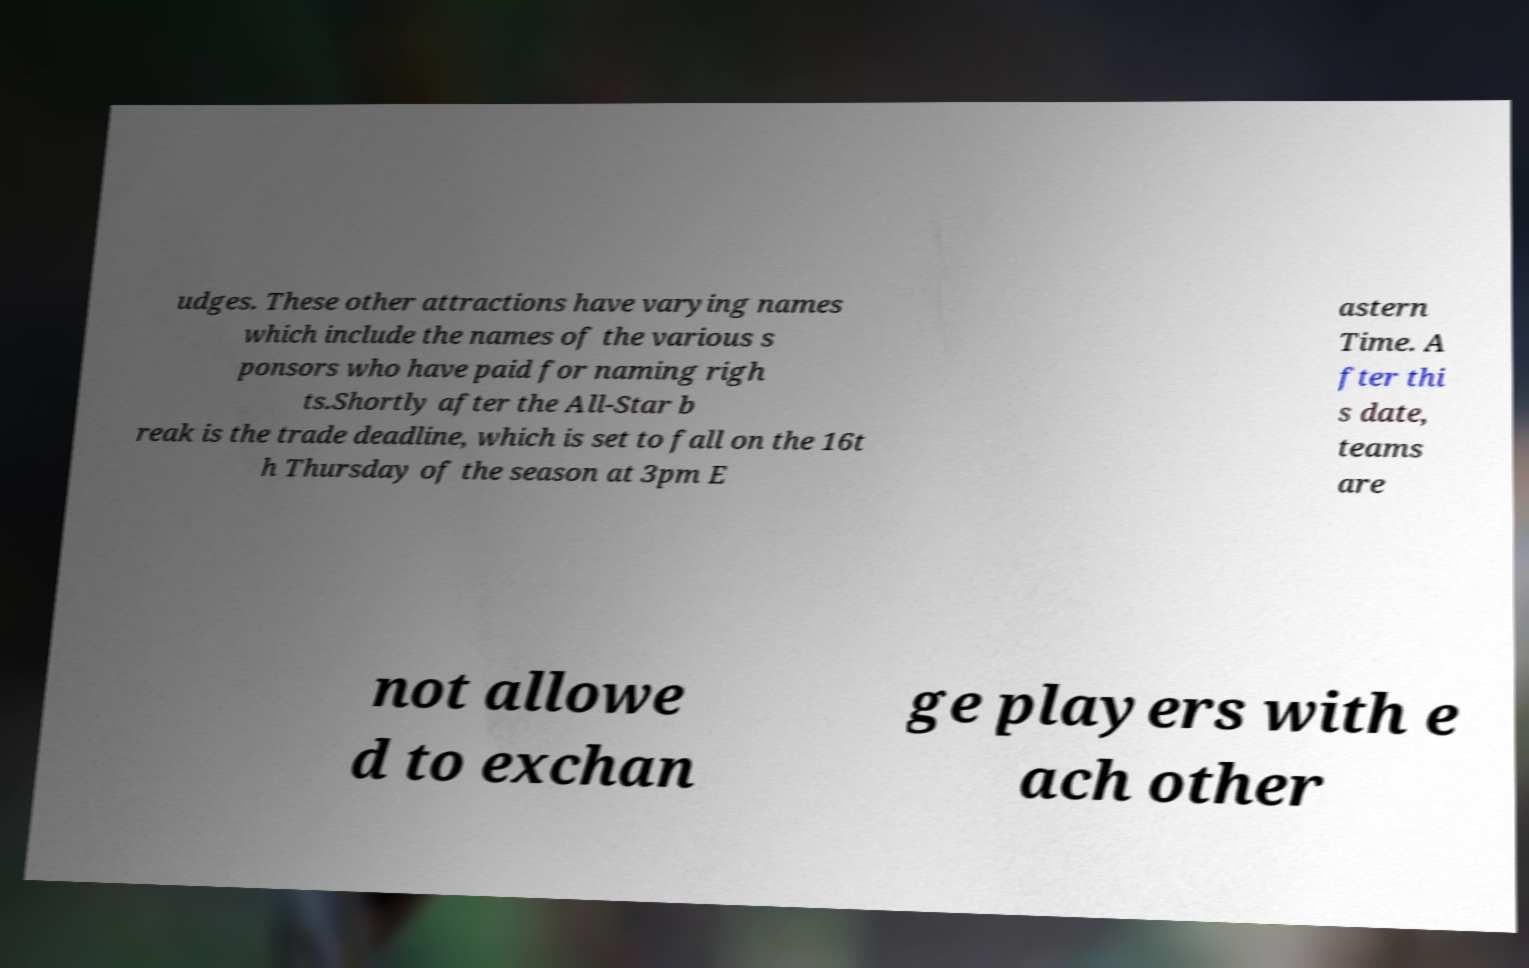Please read and relay the text visible in this image. What does it say? udges. These other attractions have varying names which include the names of the various s ponsors who have paid for naming righ ts.Shortly after the All-Star b reak is the trade deadline, which is set to fall on the 16t h Thursday of the season at 3pm E astern Time. A fter thi s date, teams are not allowe d to exchan ge players with e ach other 